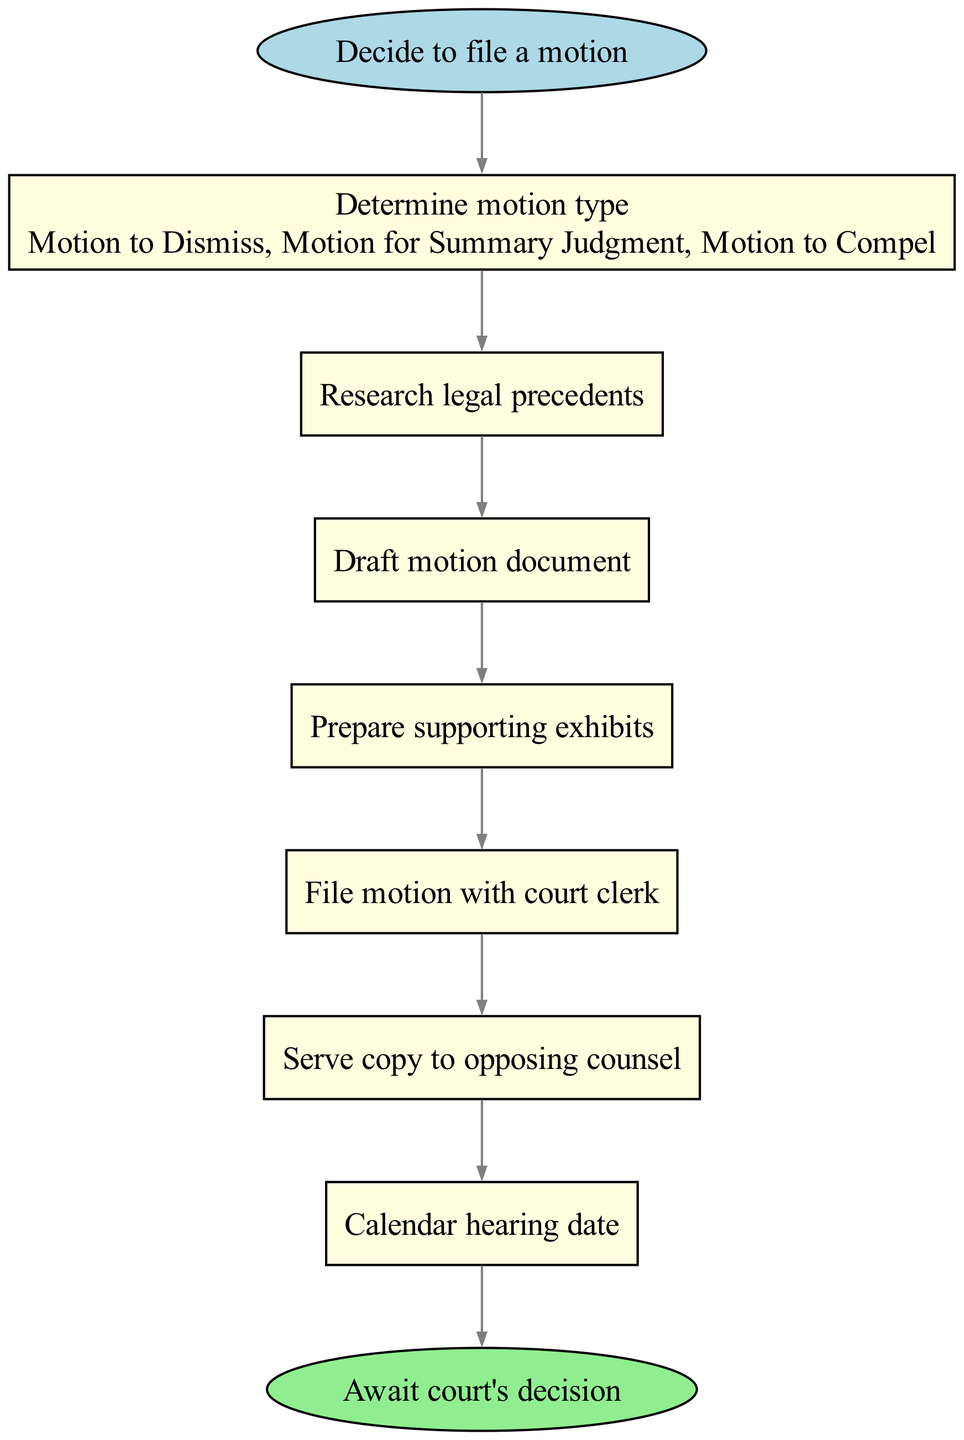What is the first step in filing a motion? The diagram begins with the step labeled as "Decide to file a motion," which is the initial action in the process.
Answer: Decide to file a motion How many types of motions are listed in the second step? The second step includes the text "Determine motion type," which lists three options: Motion to Dismiss, Motion for Summary Judgment, and Motion to Compel; therefore, the total is three types.
Answer: 3 What is the last action before awaiting the court's decision? The final step before reaching the "Await court's decision" node is "Calendar hearing date," which is the last task to be accomplished in the flow before waiting for the outcome.
Answer: Calendar hearing date What are the two main categories of actions in the diagram? The actions in the diagram can be categorized as either preliminary steps like "Determine motion type" and "Research legal precedents," or filing steps like "File motion with court clerk" and "Serve copy to opposing counsel." This creates a distinction between preparation and execution actions.
Answer: Preliminary, Filing Which step does not involve document preparation? The step "Calendar hearing date" does not involve document preparation; instead, it focuses on scheduling and is purely administrative in nature.
Answer: Calendar hearing date 